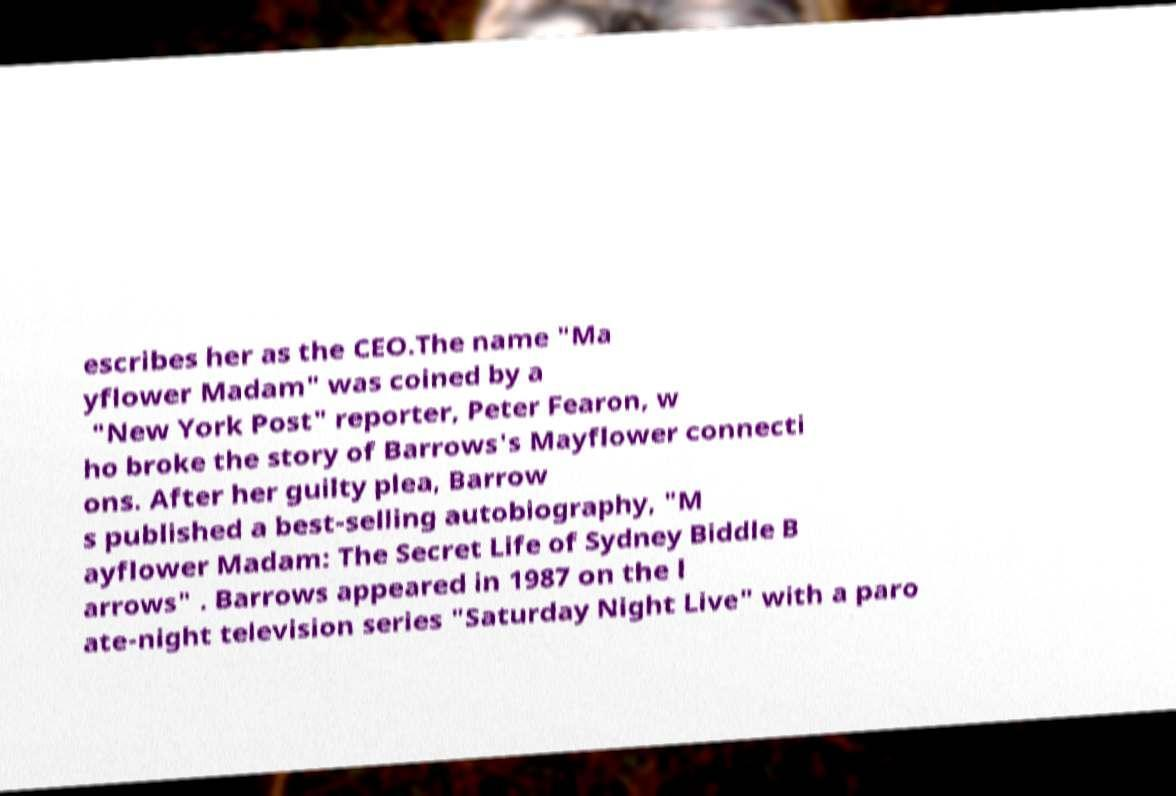Please identify and transcribe the text found in this image. escribes her as the CEO.The name "Ma yflower Madam" was coined by a "New York Post" reporter, Peter Fearon, w ho broke the story of Barrows's Mayflower connecti ons. After her guilty plea, Barrow s published a best-selling autobiography, "M ayflower Madam: The Secret Life of Sydney Biddle B arrows" . Barrows appeared in 1987 on the l ate-night television series "Saturday Night Live" with a paro 